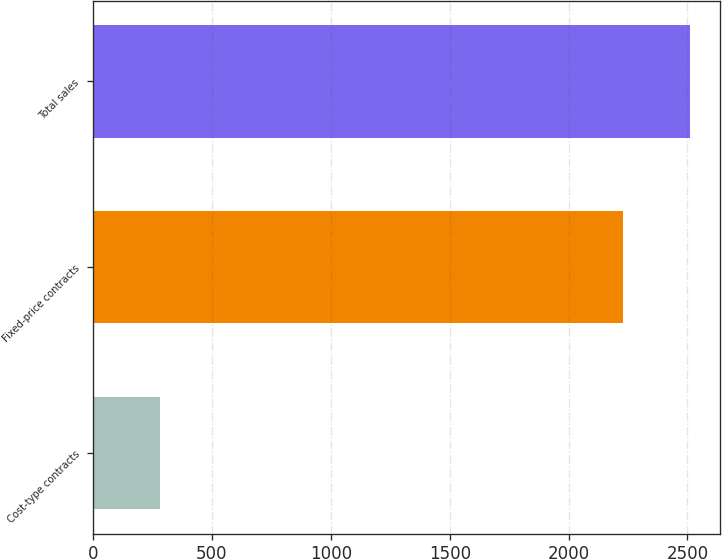<chart> <loc_0><loc_0><loc_500><loc_500><bar_chart><fcel>Cost-type contracts<fcel>Fixed-price contracts<fcel>Total sales<nl><fcel>283<fcel>2227<fcel>2510<nl></chart> 